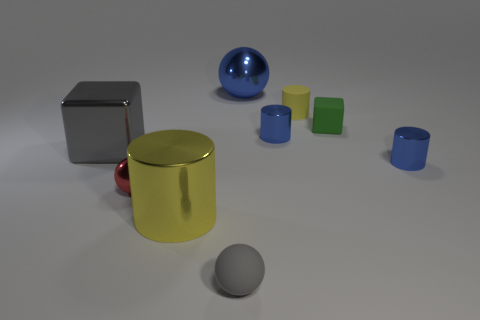There is a block that is to the right of the gray cube; is its size the same as the red ball?
Make the answer very short. Yes. The tiny metal sphere is what color?
Your response must be concise. Red. There is a matte thing to the left of the small blue metal object that is behind the large cube; what is its color?
Make the answer very short. Gray. Are there any tiny gray objects made of the same material as the small yellow cylinder?
Ensure brevity in your answer.  Yes. There is a gray object that is in front of the thing to the right of the small block; what is it made of?
Your answer should be compact. Rubber. How many big yellow metal things are the same shape as the gray shiny thing?
Your response must be concise. 0. What is the shape of the red metallic object?
Provide a succinct answer. Sphere. Is the number of large gray metallic objects less than the number of small blue blocks?
Keep it short and to the point. No. There is a gray object that is the same shape as the green matte object; what is it made of?
Give a very brief answer. Metal. Are there more yellow things than large spheres?
Your answer should be compact. Yes. 